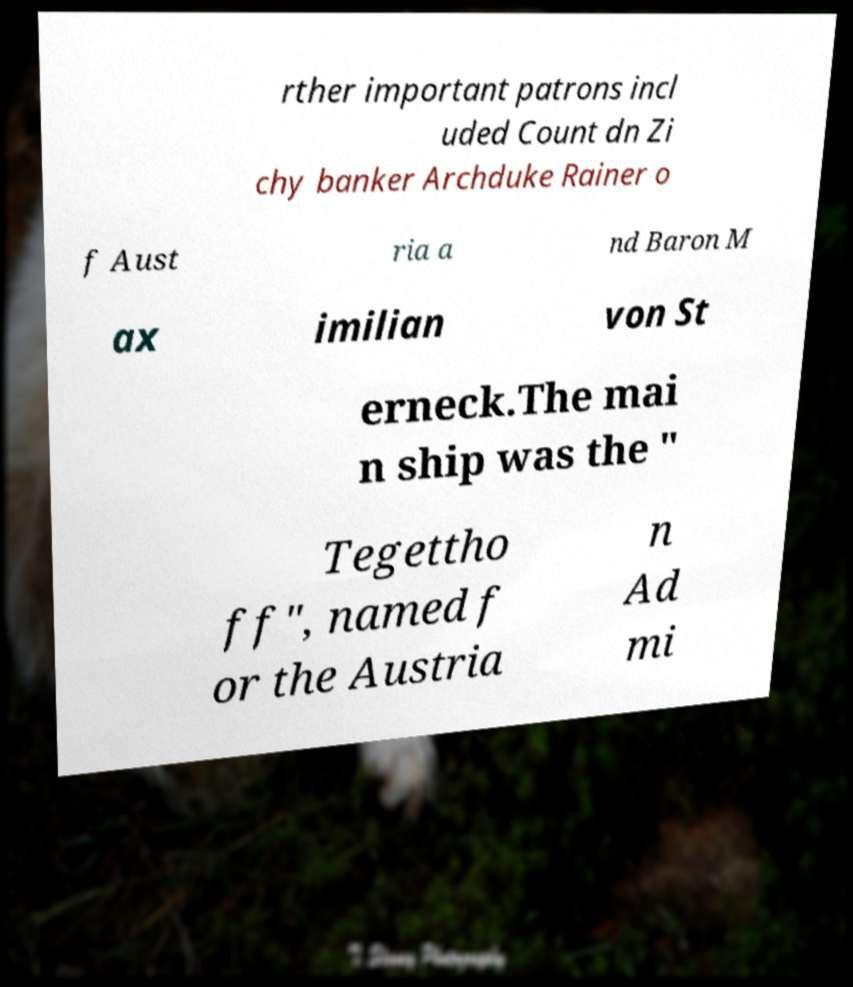Could you extract and type out the text from this image? rther important patrons incl uded Count dn Zi chy banker Archduke Rainer o f Aust ria a nd Baron M ax imilian von St erneck.The mai n ship was the " Tegettho ff", named f or the Austria n Ad mi 